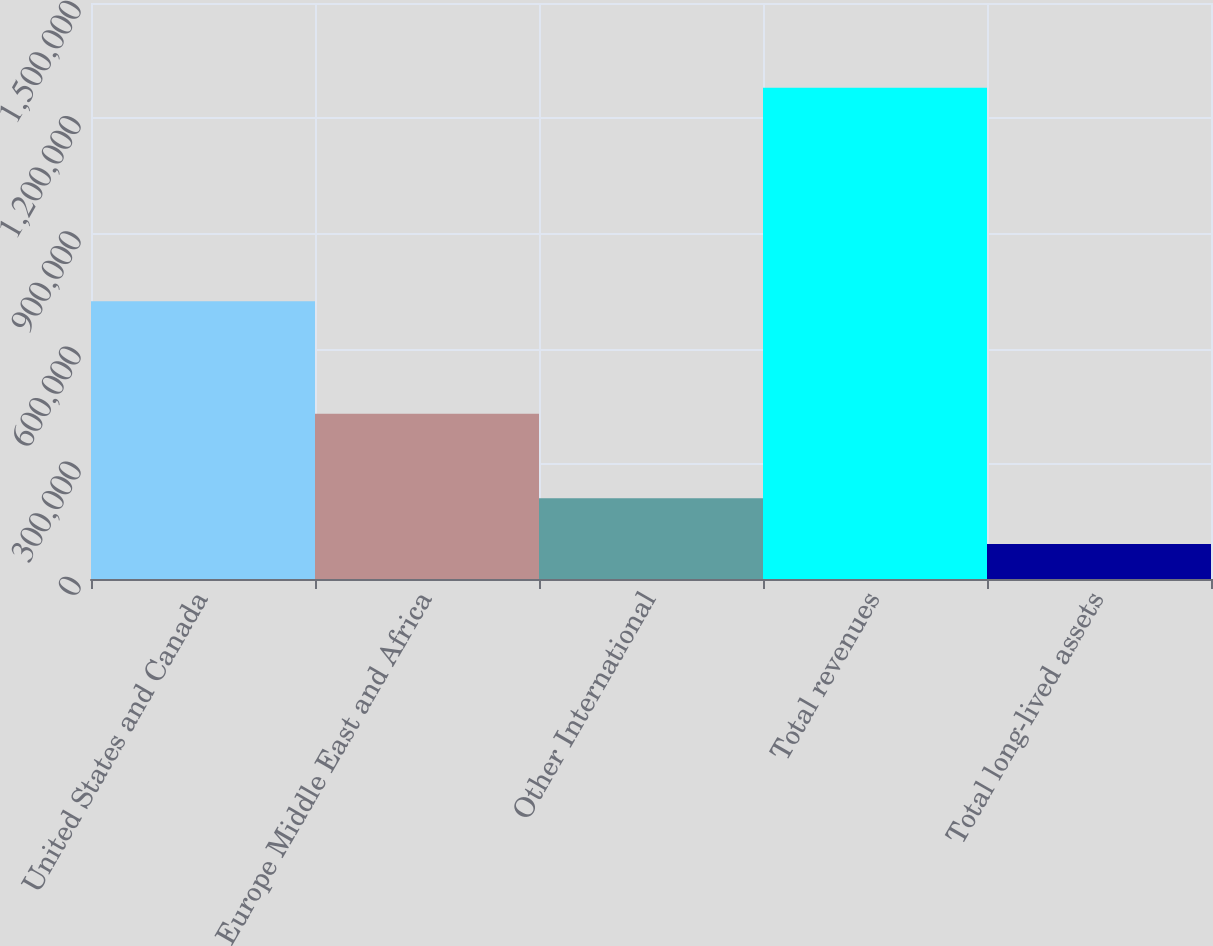Convert chart to OTSL. <chart><loc_0><loc_0><loc_500><loc_500><bar_chart><fcel>United States and Canada<fcel>Europe Middle East and Africa<fcel>Other International<fcel>Total revenues<fcel>Total long-lived assets<nl><fcel>723247<fcel>430401<fcel>210168<fcel>1.27906e+06<fcel>91402<nl></chart> 